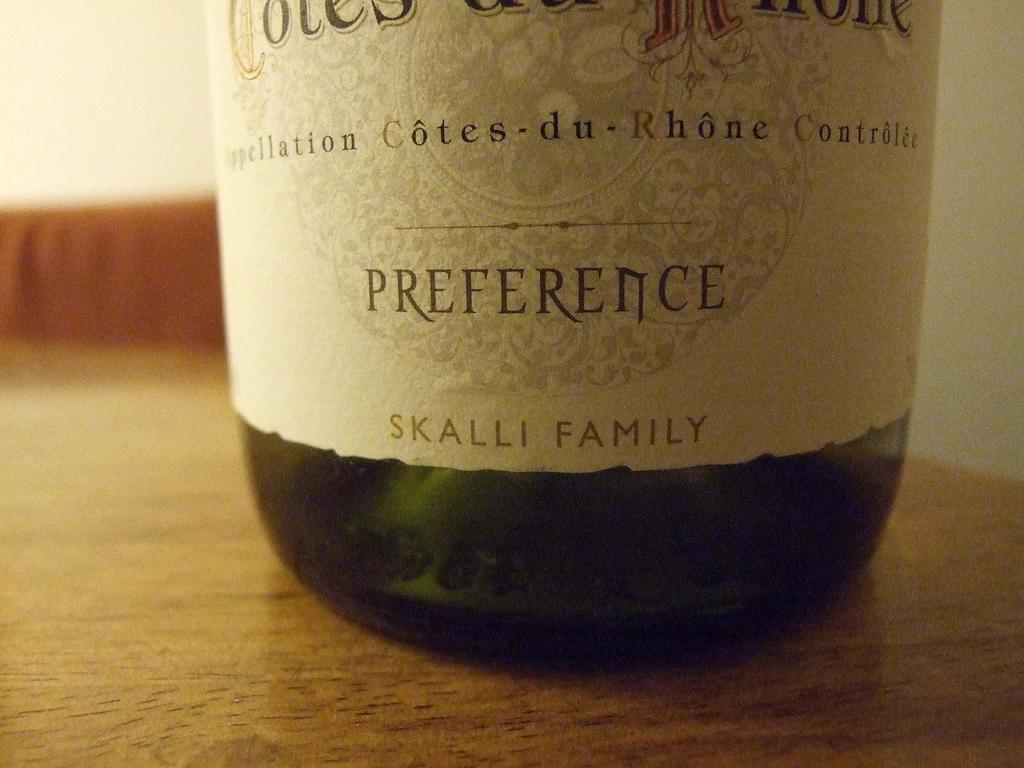<image>
Give a short and clear explanation of the subsequent image. the word preference that is on a bottle 